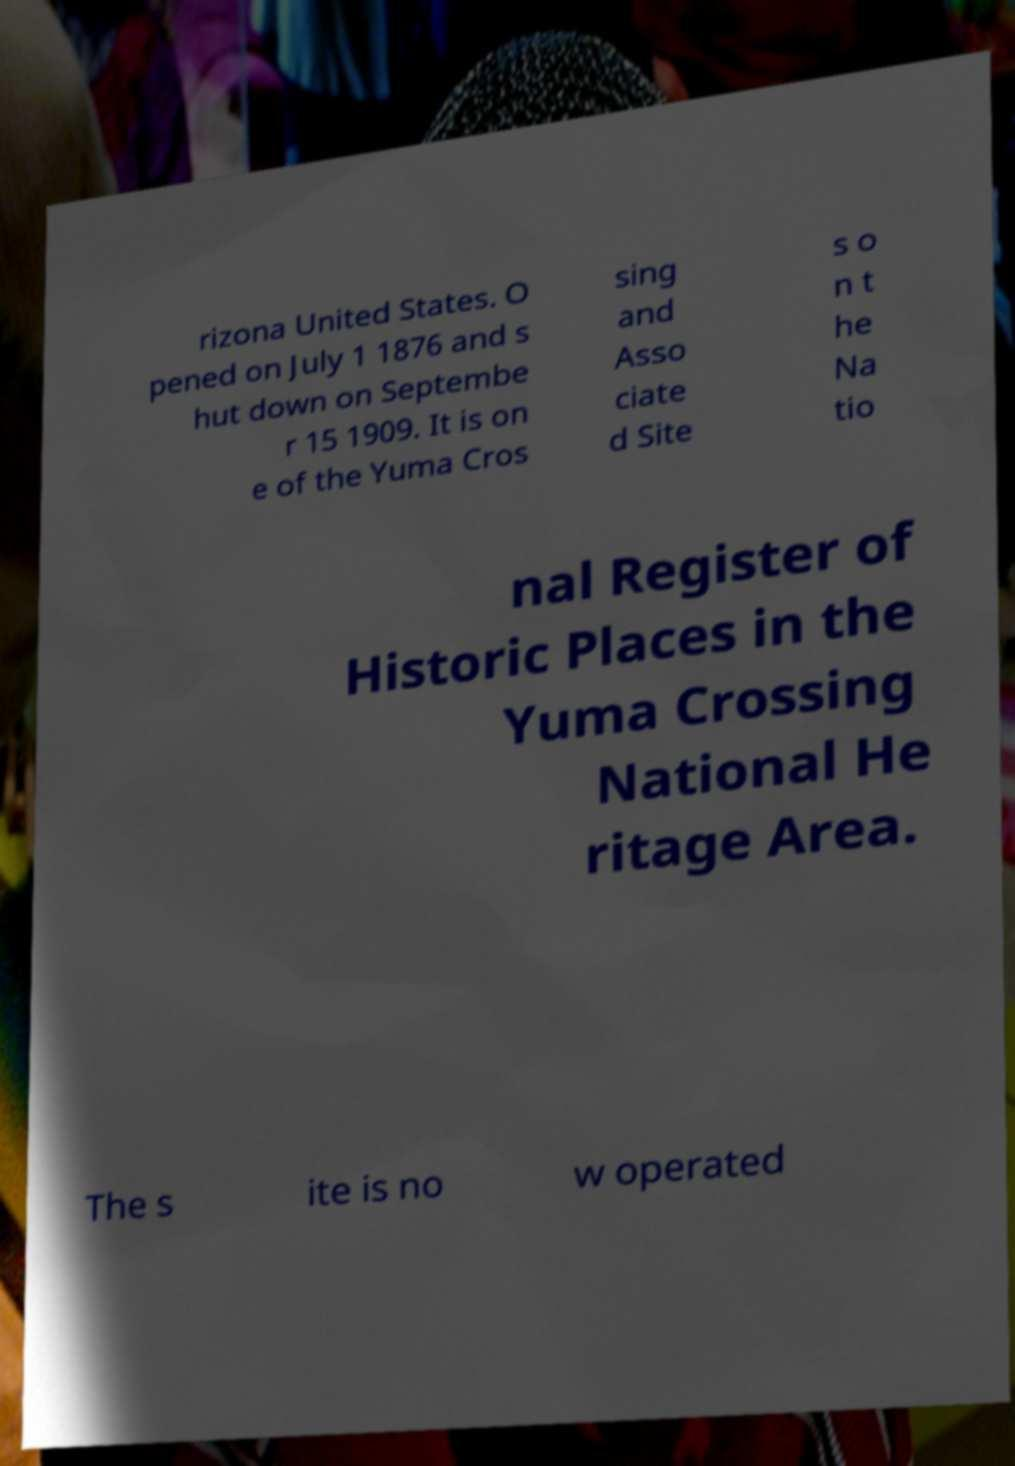For documentation purposes, I need the text within this image transcribed. Could you provide that? rizona United States. O pened on July 1 1876 and s hut down on Septembe r 15 1909. It is on e of the Yuma Cros sing and Asso ciate d Site s o n t he Na tio nal Register of Historic Places in the Yuma Crossing National He ritage Area. The s ite is no w operated 